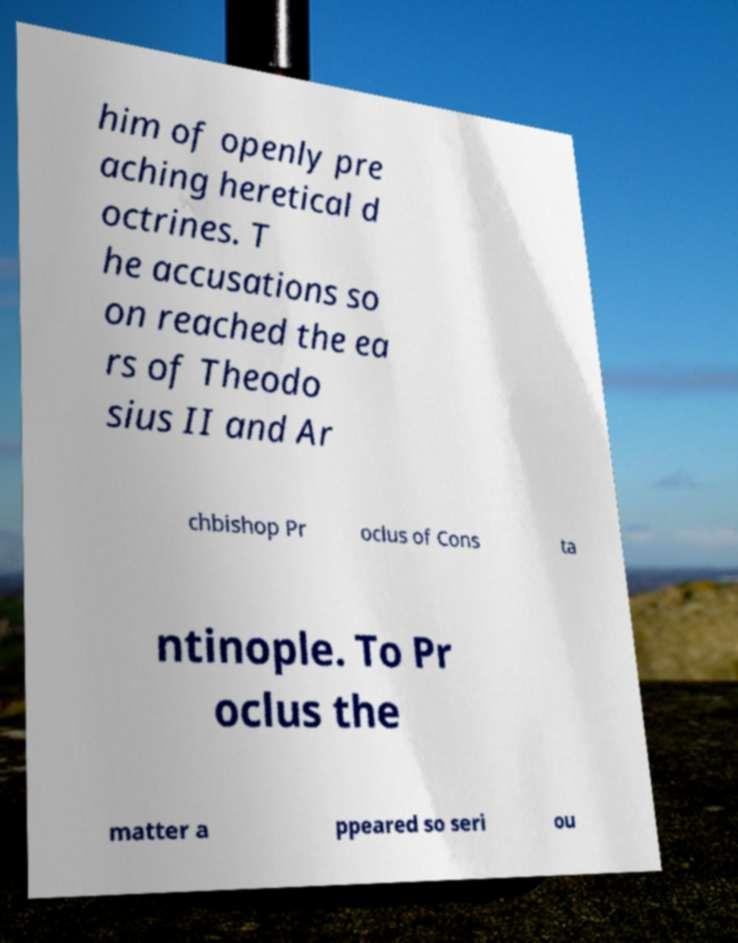Please identify and transcribe the text found in this image. him of openly pre aching heretical d octrines. T he accusations so on reached the ea rs of Theodo sius II and Ar chbishop Pr oclus of Cons ta ntinople. To Pr oclus the matter a ppeared so seri ou 